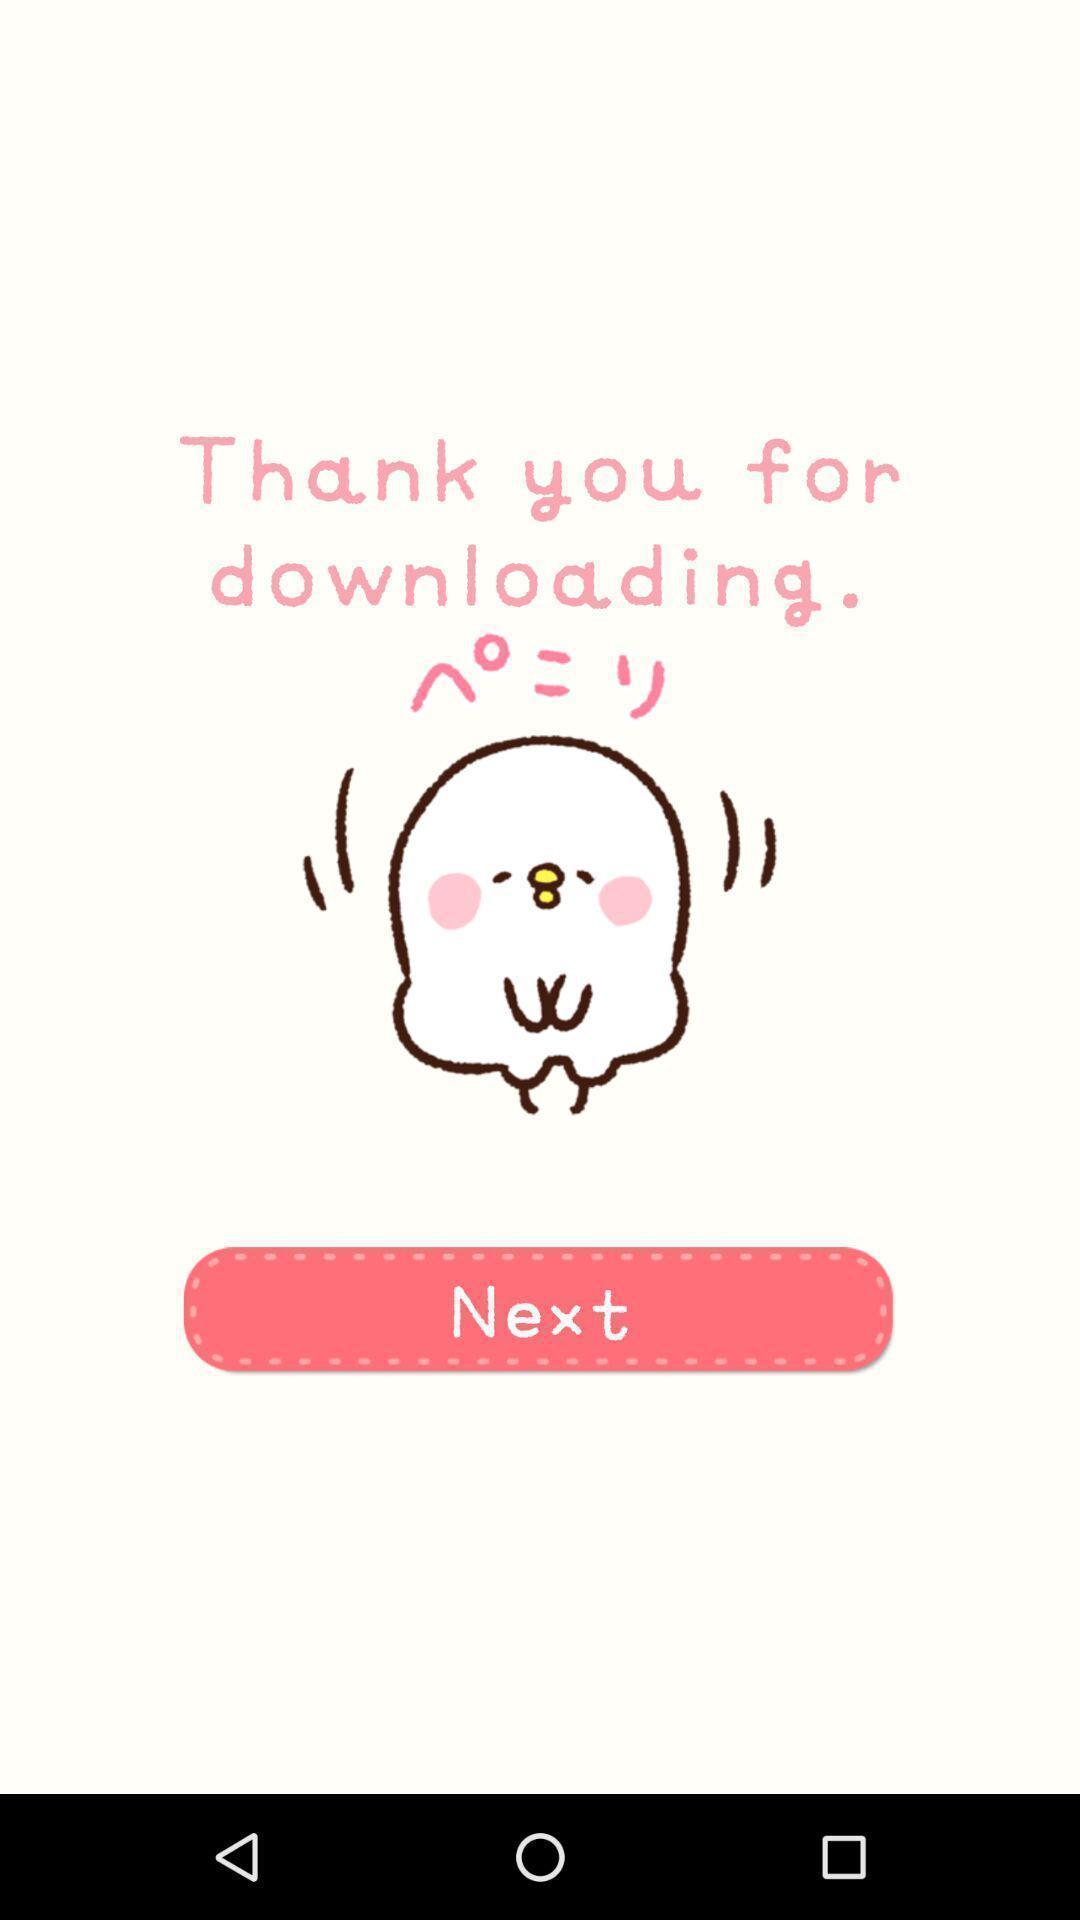Describe this image in words. Page showing option like next. 